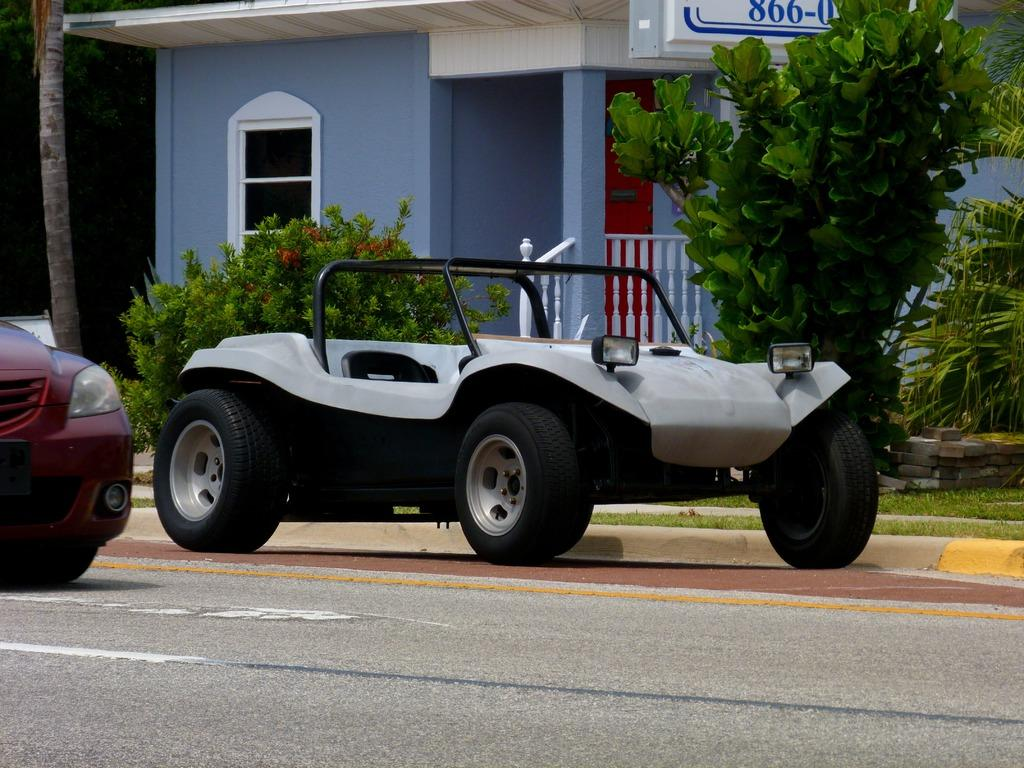How many vehicles are present in the image? There are two vehicles in the image. What type of natural elements can be seen in the image? Trees, plants, grass, and stones are present in the image. What type of structure is visible in the image? There is a house in the image. What type of pathway is visible in the image? There is a road in the image. How many sheep are grazing on the grass in the image? There are no sheep present in the image. In which direction is the house facing in the image? The image does not provide information about the direction the house is facing. 